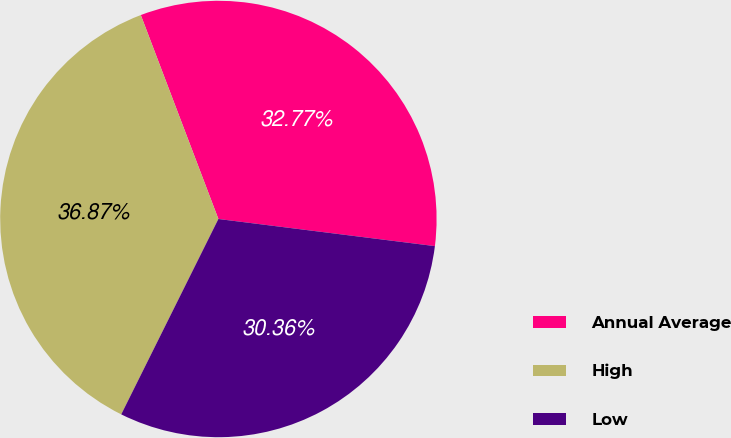Convert chart to OTSL. <chart><loc_0><loc_0><loc_500><loc_500><pie_chart><fcel>Annual Average<fcel>High<fcel>Low<nl><fcel>32.77%<fcel>36.87%<fcel>30.36%<nl></chart> 